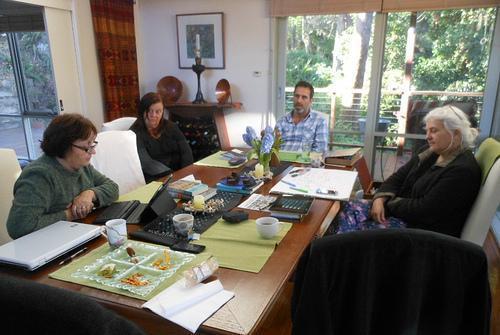How many people are in the picture?
Give a very brief answer. 4. 